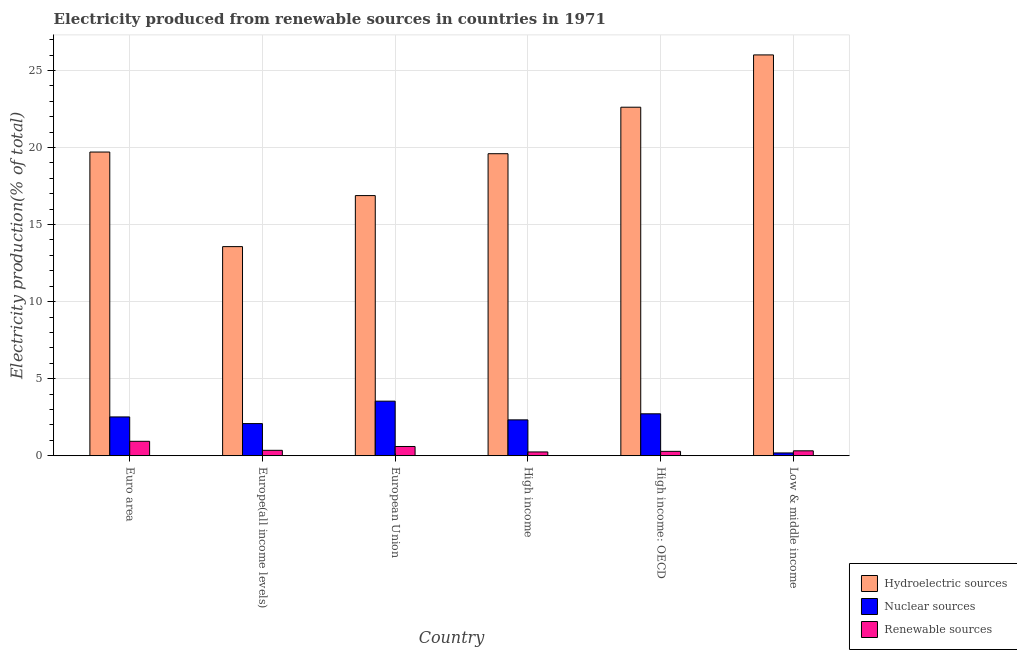How many groups of bars are there?
Your answer should be compact. 6. Are the number of bars on each tick of the X-axis equal?
Your answer should be very brief. Yes. How many bars are there on the 6th tick from the left?
Make the answer very short. 3. How many bars are there on the 4th tick from the right?
Provide a succinct answer. 3. What is the label of the 5th group of bars from the left?
Provide a succinct answer. High income: OECD. In how many cases, is the number of bars for a given country not equal to the number of legend labels?
Your answer should be compact. 0. What is the percentage of electricity produced by hydroelectric sources in High income?
Give a very brief answer. 19.6. Across all countries, what is the maximum percentage of electricity produced by nuclear sources?
Keep it short and to the point. 3.54. Across all countries, what is the minimum percentage of electricity produced by nuclear sources?
Your answer should be compact. 0.18. In which country was the percentage of electricity produced by nuclear sources maximum?
Your answer should be compact. European Union. In which country was the percentage of electricity produced by nuclear sources minimum?
Ensure brevity in your answer.  Low & middle income. What is the total percentage of electricity produced by hydroelectric sources in the graph?
Give a very brief answer. 118.38. What is the difference between the percentage of electricity produced by renewable sources in Europe(all income levels) and that in High income?
Provide a succinct answer. 0.11. What is the difference between the percentage of electricity produced by renewable sources in Euro area and the percentage of electricity produced by hydroelectric sources in Low & middle income?
Provide a short and direct response. -25.07. What is the average percentage of electricity produced by hydroelectric sources per country?
Offer a terse response. 19.73. What is the difference between the percentage of electricity produced by nuclear sources and percentage of electricity produced by renewable sources in Europe(all income levels)?
Offer a terse response. 1.74. What is the ratio of the percentage of electricity produced by nuclear sources in Euro area to that in High income?
Your answer should be very brief. 1.08. Is the difference between the percentage of electricity produced by renewable sources in Europe(all income levels) and Low & middle income greater than the difference between the percentage of electricity produced by hydroelectric sources in Europe(all income levels) and Low & middle income?
Make the answer very short. Yes. What is the difference between the highest and the second highest percentage of electricity produced by hydroelectric sources?
Offer a very short reply. 3.39. What is the difference between the highest and the lowest percentage of electricity produced by hydroelectric sources?
Your answer should be compact. 12.44. In how many countries, is the percentage of electricity produced by hydroelectric sources greater than the average percentage of electricity produced by hydroelectric sources taken over all countries?
Give a very brief answer. 2. Is the sum of the percentage of electricity produced by renewable sources in Europe(all income levels) and High income: OECD greater than the maximum percentage of electricity produced by nuclear sources across all countries?
Offer a very short reply. No. What does the 2nd bar from the left in High income: OECD represents?
Provide a succinct answer. Nuclear sources. What does the 2nd bar from the right in Euro area represents?
Give a very brief answer. Nuclear sources. Is it the case that in every country, the sum of the percentage of electricity produced by hydroelectric sources and percentage of electricity produced by nuclear sources is greater than the percentage of electricity produced by renewable sources?
Provide a succinct answer. Yes. How many bars are there?
Provide a short and direct response. 18. Are all the bars in the graph horizontal?
Make the answer very short. No. How many countries are there in the graph?
Provide a short and direct response. 6. Does the graph contain grids?
Your answer should be compact. Yes. Where does the legend appear in the graph?
Provide a short and direct response. Bottom right. How many legend labels are there?
Offer a very short reply. 3. How are the legend labels stacked?
Ensure brevity in your answer.  Vertical. What is the title of the graph?
Give a very brief answer. Electricity produced from renewable sources in countries in 1971. What is the label or title of the Y-axis?
Ensure brevity in your answer.  Electricity production(% of total). What is the Electricity production(% of total) in Hydroelectric sources in Euro area?
Your response must be concise. 19.71. What is the Electricity production(% of total) in Nuclear sources in Euro area?
Offer a terse response. 2.52. What is the Electricity production(% of total) in Renewable sources in Euro area?
Provide a succinct answer. 0.94. What is the Electricity production(% of total) in Hydroelectric sources in Europe(all income levels)?
Your answer should be very brief. 13.57. What is the Electricity production(% of total) of Nuclear sources in Europe(all income levels)?
Ensure brevity in your answer.  2.09. What is the Electricity production(% of total) of Renewable sources in Europe(all income levels)?
Provide a succinct answer. 0.35. What is the Electricity production(% of total) in Hydroelectric sources in European Union?
Offer a terse response. 16.88. What is the Electricity production(% of total) in Nuclear sources in European Union?
Make the answer very short. 3.54. What is the Electricity production(% of total) in Renewable sources in European Union?
Give a very brief answer. 0.6. What is the Electricity production(% of total) of Hydroelectric sources in High income?
Give a very brief answer. 19.6. What is the Electricity production(% of total) of Nuclear sources in High income?
Provide a short and direct response. 2.33. What is the Electricity production(% of total) in Renewable sources in High income?
Provide a short and direct response. 0.25. What is the Electricity production(% of total) in Hydroelectric sources in High income: OECD?
Give a very brief answer. 22.62. What is the Electricity production(% of total) in Nuclear sources in High income: OECD?
Offer a very short reply. 2.72. What is the Electricity production(% of total) of Renewable sources in High income: OECD?
Make the answer very short. 0.28. What is the Electricity production(% of total) in Hydroelectric sources in Low & middle income?
Ensure brevity in your answer.  26.01. What is the Electricity production(% of total) in Nuclear sources in Low & middle income?
Keep it short and to the point. 0.18. What is the Electricity production(% of total) of Renewable sources in Low & middle income?
Provide a succinct answer. 0.32. Across all countries, what is the maximum Electricity production(% of total) of Hydroelectric sources?
Your response must be concise. 26.01. Across all countries, what is the maximum Electricity production(% of total) in Nuclear sources?
Give a very brief answer. 3.54. Across all countries, what is the maximum Electricity production(% of total) of Renewable sources?
Offer a very short reply. 0.94. Across all countries, what is the minimum Electricity production(% of total) of Hydroelectric sources?
Your response must be concise. 13.57. Across all countries, what is the minimum Electricity production(% of total) in Nuclear sources?
Give a very brief answer. 0.18. Across all countries, what is the minimum Electricity production(% of total) of Renewable sources?
Provide a succinct answer. 0.25. What is the total Electricity production(% of total) in Hydroelectric sources in the graph?
Your response must be concise. 118.38. What is the total Electricity production(% of total) in Nuclear sources in the graph?
Provide a succinct answer. 13.37. What is the total Electricity production(% of total) in Renewable sources in the graph?
Your answer should be compact. 2.73. What is the difference between the Electricity production(% of total) in Hydroelectric sources in Euro area and that in Europe(all income levels)?
Keep it short and to the point. 6.14. What is the difference between the Electricity production(% of total) of Nuclear sources in Euro area and that in Europe(all income levels)?
Ensure brevity in your answer.  0.43. What is the difference between the Electricity production(% of total) in Renewable sources in Euro area and that in Europe(all income levels)?
Your response must be concise. 0.58. What is the difference between the Electricity production(% of total) of Hydroelectric sources in Euro area and that in European Union?
Provide a succinct answer. 2.83. What is the difference between the Electricity production(% of total) in Nuclear sources in Euro area and that in European Union?
Offer a very short reply. -1.02. What is the difference between the Electricity production(% of total) in Renewable sources in Euro area and that in European Union?
Offer a very short reply. 0.34. What is the difference between the Electricity production(% of total) in Hydroelectric sources in Euro area and that in High income?
Make the answer very short. 0.11. What is the difference between the Electricity production(% of total) of Nuclear sources in Euro area and that in High income?
Provide a succinct answer. 0.19. What is the difference between the Electricity production(% of total) of Renewable sources in Euro area and that in High income?
Give a very brief answer. 0.69. What is the difference between the Electricity production(% of total) of Hydroelectric sources in Euro area and that in High income: OECD?
Ensure brevity in your answer.  -2.91. What is the difference between the Electricity production(% of total) of Nuclear sources in Euro area and that in High income: OECD?
Offer a very short reply. -0.2. What is the difference between the Electricity production(% of total) in Renewable sources in Euro area and that in High income: OECD?
Keep it short and to the point. 0.65. What is the difference between the Electricity production(% of total) of Hydroelectric sources in Euro area and that in Low & middle income?
Offer a terse response. -6.3. What is the difference between the Electricity production(% of total) in Nuclear sources in Euro area and that in Low & middle income?
Give a very brief answer. 2.34. What is the difference between the Electricity production(% of total) in Renewable sources in Euro area and that in Low & middle income?
Your answer should be compact. 0.62. What is the difference between the Electricity production(% of total) in Hydroelectric sources in Europe(all income levels) and that in European Union?
Make the answer very short. -3.31. What is the difference between the Electricity production(% of total) of Nuclear sources in Europe(all income levels) and that in European Union?
Make the answer very short. -1.45. What is the difference between the Electricity production(% of total) of Renewable sources in Europe(all income levels) and that in European Union?
Your answer should be compact. -0.25. What is the difference between the Electricity production(% of total) of Hydroelectric sources in Europe(all income levels) and that in High income?
Keep it short and to the point. -6.03. What is the difference between the Electricity production(% of total) of Nuclear sources in Europe(all income levels) and that in High income?
Your answer should be very brief. -0.24. What is the difference between the Electricity production(% of total) in Renewable sources in Europe(all income levels) and that in High income?
Offer a very short reply. 0.11. What is the difference between the Electricity production(% of total) of Hydroelectric sources in Europe(all income levels) and that in High income: OECD?
Your answer should be very brief. -9.05. What is the difference between the Electricity production(% of total) of Nuclear sources in Europe(all income levels) and that in High income: OECD?
Provide a short and direct response. -0.63. What is the difference between the Electricity production(% of total) in Renewable sources in Europe(all income levels) and that in High income: OECD?
Offer a terse response. 0.07. What is the difference between the Electricity production(% of total) of Hydroelectric sources in Europe(all income levels) and that in Low & middle income?
Provide a succinct answer. -12.44. What is the difference between the Electricity production(% of total) in Nuclear sources in Europe(all income levels) and that in Low & middle income?
Provide a short and direct response. 1.9. What is the difference between the Electricity production(% of total) in Renewable sources in Europe(all income levels) and that in Low & middle income?
Offer a very short reply. 0.03. What is the difference between the Electricity production(% of total) in Hydroelectric sources in European Union and that in High income?
Give a very brief answer. -2.72. What is the difference between the Electricity production(% of total) of Nuclear sources in European Union and that in High income?
Make the answer very short. 1.21. What is the difference between the Electricity production(% of total) in Renewable sources in European Union and that in High income?
Offer a terse response. 0.35. What is the difference between the Electricity production(% of total) of Hydroelectric sources in European Union and that in High income: OECD?
Ensure brevity in your answer.  -5.74. What is the difference between the Electricity production(% of total) in Nuclear sources in European Union and that in High income: OECD?
Provide a succinct answer. 0.82. What is the difference between the Electricity production(% of total) in Renewable sources in European Union and that in High income: OECD?
Offer a terse response. 0.32. What is the difference between the Electricity production(% of total) in Hydroelectric sources in European Union and that in Low & middle income?
Make the answer very short. -9.13. What is the difference between the Electricity production(% of total) of Nuclear sources in European Union and that in Low & middle income?
Your response must be concise. 3.36. What is the difference between the Electricity production(% of total) of Renewable sources in European Union and that in Low & middle income?
Your answer should be compact. 0.28. What is the difference between the Electricity production(% of total) in Hydroelectric sources in High income and that in High income: OECD?
Give a very brief answer. -3.02. What is the difference between the Electricity production(% of total) of Nuclear sources in High income and that in High income: OECD?
Make the answer very short. -0.39. What is the difference between the Electricity production(% of total) of Renewable sources in High income and that in High income: OECD?
Make the answer very short. -0.04. What is the difference between the Electricity production(% of total) in Hydroelectric sources in High income and that in Low & middle income?
Offer a very short reply. -6.41. What is the difference between the Electricity production(% of total) in Nuclear sources in High income and that in Low & middle income?
Provide a short and direct response. 2.15. What is the difference between the Electricity production(% of total) of Renewable sources in High income and that in Low & middle income?
Provide a short and direct response. -0.07. What is the difference between the Electricity production(% of total) in Hydroelectric sources in High income: OECD and that in Low & middle income?
Ensure brevity in your answer.  -3.39. What is the difference between the Electricity production(% of total) in Nuclear sources in High income: OECD and that in Low & middle income?
Your answer should be very brief. 2.54. What is the difference between the Electricity production(% of total) of Renewable sources in High income: OECD and that in Low & middle income?
Provide a short and direct response. -0.03. What is the difference between the Electricity production(% of total) of Hydroelectric sources in Euro area and the Electricity production(% of total) of Nuclear sources in Europe(all income levels)?
Your response must be concise. 17.62. What is the difference between the Electricity production(% of total) of Hydroelectric sources in Euro area and the Electricity production(% of total) of Renewable sources in Europe(all income levels)?
Your answer should be compact. 19.36. What is the difference between the Electricity production(% of total) of Nuclear sources in Euro area and the Electricity production(% of total) of Renewable sources in Europe(all income levels)?
Offer a terse response. 2.17. What is the difference between the Electricity production(% of total) of Hydroelectric sources in Euro area and the Electricity production(% of total) of Nuclear sources in European Union?
Your answer should be compact. 16.17. What is the difference between the Electricity production(% of total) of Hydroelectric sources in Euro area and the Electricity production(% of total) of Renewable sources in European Union?
Provide a short and direct response. 19.11. What is the difference between the Electricity production(% of total) in Nuclear sources in Euro area and the Electricity production(% of total) in Renewable sources in European Union?
Ensure brevity in your answer.  1.92. What is the difference between the Electricity production(% of total) in Hydroelectric sources in Euro area and the Electricity production(% of total) in Nuclear sources in High income?
Your answer should be very brief. 17.38. What is the difference between the Electricity production(% of total) in Hydroelectric sources in Euro area and the Electricity production(% of total) in Renewable sources in High income?
Ensure brevity in your answer.  19.46. What is the difference between the Electricity production(% of total) of Nuclear sources in Euro area and the Electricity production(% of total) of Renewable sources in High income?
Your response must be concise. 2.27. What is the difference between the Electricity production(% of total) in Hydroelectric sources in Euro area and the Electricity production(% of total) in Nuclear sources in High income: OECD?
Your answer should be compact. 16.99. What is the difference between the Electricity production(% of total) in Hydroelectric sources in Euro area and the Electricity production(% of total) in Renewable sources in High income: OECD?
Give a very brief answer. 19.42. What is the difference between the Electricity production(% of total) of Nuclear sources in Euro area and the Electricity production(% of total) of Renewable sources in High income: OECD?
Provide a short and direct response. 2.23. What is the difference between the Electricity production(% of total) in Hydroelectric sources in Euro area and the Electricity production(% of total) in Nuclear sources in Low & middle income?
Keep it short and to the point. 19.53. What is the difference between the Electricity production(% of total) of Hydroelectric sources in Euro area and the Electricity production(% of total) of Renewable sources in Low & middle income?
Keep it short and to the point. 19.39. What is the difference between the Electricity production(% of total) of Nuclear sources in Euro area and the Electricity production(% of total) of Renewable sources in Low & middle income?
Ensure brevity in your answer.  2.2. What is the difference between the Electricity production(% of total) of Hydroelectric sources in Europe(all income levels) and the Electricity production(% of total) of Nuclear sources in European Union?
Offer a terse response. 10.03. What is the difference between the Electricity production(% of total) in Hydroelectric sources in Europe(all income levels) and the Electricity production(% of total) in Renewable sources in European Union?
Offer a very short reply. 12.97. What is the difference between the Electricity production(% of total) of Nuclear sources in Europe(all income levels) and the Electricity production(% of total) of Renewable sources in European Union?
Keep it short and to the point. 1.49. What is the difference between the Electricity production(% of total) in Hydroelectric sources in Europe(all income levels) and the Electricity production(% of total) in Nuclear sources in High income?
Your answer should be compact. 11.24. What is the difference between the Electricity production(% of total) of Hydroelectric sources in Europe(all income levels) and the Electricity production(% of total) of Renewable sources in High income?
Keep it short and to the point. 13.32. What is the difference between the Electricity production(% of total) of Nuclear sources in Europe(all income levels) and the Electricity production(% of total) of Renewable sources in High income?
Your answer should be compact. 1.84. What is the difference between the Electricity production(% of total) in Hydroelectric sources in Europe(all income levels) and the Electricity production(% of total) in Nuclear sources in High income: OECD?
Ensure brevity in your answer.  10.85. What is the difference between the Electricity production(% of total) of Hydroelectric sources in Europe(all income levels) and the Electricity production(% of total) of Renewable sources in High income: OECD?
Keep it short and to the point. 13.29. What is the difference between the Electricity production(% of total) in Nuclear sources in Europe(all income levels) and the Electricity production(% of total) in Renewable sources in High income: OECD?
Your answer should be compact. 1.8. What is the difference between the Electricity production(% of total) in Hydroelectric sources in Europe(all income levels) and the Electricity production(% of total) in Nuclear sources in Low & middle income?
Give a very brief answer. 13.39. What is the difference between the Electricity production(% of total) in Hydroelectric sources in Europe(all income levels) and the Electricity production(% of total) in Renewable sources in Low & middle income?
Your response must be concise. 13.25. What is the difference between the Electricity production(% of total) in Nuclear sources in Europe(all income levels) and the Electricity production(% of total) in Renewable sources in Low & middle income?
Keep it short and to the point. 1.77. What is the difference between the Electricity production(% of total) in Hydroelectric sources in European Union and the Electricity production(% of total) in Nuclear sources in High income?
Keep it short and to the point. 14.55. What is the difference between the Electricity production(% of total) of Hydroelectric sources in European Union and the Electricity production(% of total) of Renewable sources in High income?
Your answer should be compact. 16.64. What is the difference between the Electricity production(% of total) of Nuclear sources in European Union and the Electricity production(% of total) of Renewable sources in High income?
Keep it short and to the point. 3.3. What is the difference between the Electricity production(% of total) of Hydroelectric sources in European Union and the Electricity production(% of total) of Nuclear sources in High income: OECD?
Make the answer very short. 14.16. What is the difference between the Electricity production(% of total) in Hydroelectric sources in European Union and the Electricity production(% of total) in Renewable sources in High income: OECD?
Offer a very short reply. 16.6. What is the difference between the Electricity production(% of total) in Nuclear sources in European Union and the Electricity production(% of total) in Renewable sources in High income: OECD?
Provide a succinct answer. 3.26. What is the difference between the Electricity production(% of total) in Hydroelectric sources in European Union and the Electricity production(% of total) in Nuclear sources in Low & middle income?
Your answer should be compact. 16.7. What is the difference between the Electricity production(% of total) in Hydroelectric sources in European Union and the Electricity production(% of total) in Renewable sources in Low & middle income?
Provide a short and direct response. 16.56. What is the difference between the Electricity production(% of total) of Nuclear sources in European Union and the Electricity production(% of total) of Renewable sources in Low & middle income?
Offer a very short reply. 3.22. What is the difference between the Electricity production(% of total) of Hydroelectric sources in High income and the Electricity production(% of total) of Nuclear sources in High income: OECD?
Your answer should be compact. 16.88. What is the difference between the Electricity production(% of total) in Hydroelectric sources in High income and the Electricity production(% of total) in Renewable sources in High income: OECD?
Give a very brief answer. 19.31. What is the difference between the Electricity production(% of total) in Nuclear sources in High income and the Electricity production(% of total) in Renewable sources in High income: OECD?
Provide a short and direct response. 2.04. What is the difference between the Electricity production(% of total) in Hydroelectric sources in High income and the Electricity production(% of total) in Nuclear sources in Low & middle income?
Your answer should be very brief. 19.42. What is the difference between the Electricity production(% of total) in Hydroelectric sources in High income and the Electricity production(% of total) in Renewable sources in Low & middle income?
Provide a succinct answer. 19.28. What is the difference between the Electricity production(% of total) in Nuclear sources in High income and the Electricity production(% of total) in Renewable sources in Low & middle income?
Your answer should be very brief. 2.01. What is the difference between the Electricity production(% of total) of Hydroelectric sources in High income: OECD and the Electricity production(% of total) of Nuclear sources in Low & middle income?
Ensure brevity in your answer.  22.43. What is the difference between the Electricity production(% of total) in Hydroelectric sources in High income: OECD and the Electricity production(% of total) in Renewable sources in Low & middle income?
Offer a terse response. 22.3. What is the difference between the Electricity production(% of total) in Nuclear sources in High income: OECD and the Electricity production(% of total) in Renewable sources in Low & middle income?
Ensure brevity in your answer.  2.4. What is the average Electricity production(% of total) of Hydroelectric sources per country?
Ensure brevity in your answer.  19.73. What is the average Electricity production(% of total) of Nuclear sources per country?
Make the answer very short. 2.23. What is the average Electricity production(% of total) of Renewable sources per country?
Keep it short and to the point. 0.46. What is the difference between the Electricity production(% of total) in Hydroelectric sources and Electricity production(% of total) in Nuclear sources in Euro area?
Your response must be concise. 17.19. What is the difference between the Electricity production(% of total) of Hydroelectric sources and Electricity production(% of total) of Renewable sources in Euro area?
Your response must be concise. 18.77. What is the difference between the Electricity production(% of total) of Nuclear sources and Electricity production(% of total) of Renewable sources in Euro area?
Your response must be concise. 1.58. What is the difference between the Electricity production(% of total) in Hydroelectric sources and Electricity production(% of total) in Nuclear sources in Europe(all income levels)?
Your answer should be compact. 11.48. What is the difference between the Electricity production(% of total) of Hydroelectric sources and Electricity production(% of total) of Renewable sources in Europe(all income levels)?
Offer a terse response. 13.22. What is the difference between the Electricity production(% of total) of Nuclear sources and Electricity production(% of total) of Renewable sources in Europe(all income levels)?
Make the answer very short. 1.74. What is the difference between the Electricity production(% of total) of Hydroelectric sources and Electricity production(% of total) of Nuclear sources in European Union?
Provide a short and direct response. 13.34. What is the difference between the Electricity production(% of total) of Hydroelectric sources and Electricity production(% of total) of Renewable sources in European Union?
Provide a succinct answer. 16.28. What is the difference between the Electricity production(% of total) in Nuclear sources and Electricity production(% of total) in Renewable sources in European Union?
Your answer should be very brief. 2.94. What is the difference between the Electricity production(% of total) of Hydroelectric sources and Electricity production(% of total) of Nuclear sources in High income?
Your answer should be compact. 17.27. What is the difference between the Electricity production(% of total) of Hydroelectric sources and Electricity production(% of total) of Renewable sources in High income?
Keep it short and to the point. 19.35. What is the difference between the Electricity production(% of total) in Nuclear sources and Electricity production(% of total) in Renewable sources in High income?
Keep it short and to the point. 2.08. What is the difference between the Electricity production(% of total) of Hydroelectric sources and Electricity production(% of total) of Nuclear sources in High income: OECD?
Provide a succinct answer. 19.89. What is the difference between the Electricity production(% of total) of Hydroelectric sources and Electricity production(% of total) of Renewable sources in High income: OECD?
Your response must be concise. 22.33. What is the difference between the Electricity production(% of total) of Nuclear sources and Electricity production(% of total) of Renewable sources in High income: OECD?
Your answer should be very brief. 2.44. What is the difference between the Electricity production(% of total) of Hydroelectric sources and Electricity production(% of total) of Nuclear sources in Low & middle income?
Give a very brief answer. 25.83. What is the difference between the Electricity production(% of total) in Hydroelectric sources and Electricity production(% of total) in Renewable sources in Low & middle income?
Offer a very short reply. 25.69. What is the difference between the Electricity production(% of total) in Nuclear sources and Electricity production(% of total) in Renewable sources in Low & middle income?
Your answer should be very brief. -0.14. What is the ratio of the Electricity production(% of total) in Hydroelectric sources in Euro area to that in Europe(all income levels)?
Provide a succinct answer. 1.45. What is the ratio of the Electricity production(% of total) in Nuclear sources in Euro area to that in Europe(all income levels)?
Your response must be concise. 1.21. What is the ratio of the Electricity production(% of total) in Renewable sources in Euro area to that in Europe(all income levels)?
Ensure brevity in your answer.  2.67. What is the ratio of the Electricity production(% of total) in Hydroelectric sources in Euro area to that in European Union?
Ensure brevity in your answer.  1.17. What is the ratio of the Electricity production(% of total) of Nuclear sources in Euro area to that in European Union?
Your answer should be very brief. 0.71. What is the ratio of the Electricity production(% of total) in Renewable sources in Euro area to that in European Union?
Your response must be concise. 1.56. What is the ratio of the Electricity production(% of total) of Hydroelectric sources in Euro area to that in High income?
Provide a short and direct response. 1.01. What is the ratio of the Electricity production(% of total) in Nuclear sources in Euro area to that in High income?
Give a very brief answer. 1.08. What is the ratio of the Electricity production(% of total) in Renewable sources in Euro area to that in High income?
Give a very brief answer. 3.82. What is the ratio of the Electricity production(% of total) of Hydroelectric sources in Euro area to that in High income: OECD?
Make the answer very short. 0.87. What is the ratio of the Electricity production(% of total) of Nuclear sources in Euro area to that in High income: OECD?
Your answer should be compact. 0.93. What is the ratio of the Electricity production(% of total) in Renewable sources in Euro area to that in High income: OECD?
Ensure brevity in your answer.  3.3. What is the ratio of the Electricity production(% of total) in Hydroelectric sources in Euro area to that in Low & middle income?
Provide a short and direct response. 0.76. What is the ratio of the Electricity production(% of total) in Nuclear sources in Euro area to that in Low & middle income?
Your answer should be compact. 13.88. What is the ratio of the Electricity production(% of total) in Renewable sources in Euro area to that in Low & middle income?
Ensure brevity in your answer.  2.94. What is the ratio of the Electricity production(% of total) in Hydroelectric sources in Europe(all income levels) to that in European Union?
Offer a very short reply. 0.8. What is the ratio of the Electricity production(% of total) of Nuclear sources in Europe(all income levels) to that in European Union?
Your answer should be very brief. 0.59. What is the ratio of the Electricity production(% of total) of Renewable sources in Europe(all income levels) to that in European Union?
Offer a terse response. 0.59. What is the ratio of the Electricity production(% of total) of Hydroelectric sources in Europe(all income levels) to that in High income?
Offer a very short reply. 0.69. What is the ratio of the Electricity production(% of total) in Nuclear sources in Europe(all income levels) to that in High income?
Keep it short and to the point. 0.9. What is the ratio of the Electricity production(% of total) in Renewable sources in Europe(all income levels) to that in High income?
Provide a succinct answer. 1.43. What is the ratio of the Electricity production(% of total) of Hydroelectric sources in Europe(all income levels) to that in High income: OECD?
Offer a terse response. 0.6. What is the ratio of the Electricity production(% of total) of Nuclear sources in Europe(all income levels) to that in High income: OECD?
Your answer should be compact. 0.77. What is the ratio of the Electricity production(% of total) of Renewable sources in Europe(all income levels) to that in High income: OECD?
Offer a very short reply. 1.24. What is the ratio of the Electricity production(% of total) of Hydroelectric sources in Europe(all income levels) to that in Low & middle income?
Give a very brief answer. 0.52. What is the ratio of the Electricity production(% of total) in Nuclear sources in Europe(all income levels) to that in Low & middle income?
Offer a terse response. 11.5. What is the ratio of the Electricity production(% of total) of Renewable sources in Europe(all income levels) to that in Low & middle income?
Offer a very short reply. 1.1. What is the ratio of the Electricity production(% of total) in Hydroelectric sources in European Union to that in High income?
Ensure brevity in your answer.  0.86. What is the ratio of the Electricity production(% of total) in Nuclear sources in European Union to that in High income?
Keep it short and to the point. 1.52. What is the ratio of the Electricity production(% of total) of Renewable sources in European Union to that in High income?
Provide a succinct answer. 2.45. What is the ratio of the Electricity production(% of total) in Hydroelectric sources in European Union to that in High income: OECD?
Offer a very short reply. 0.75. What is the ratio of the Electricity production(% of total) in Nuclear sources in European Union to that in High income: OECD?
Provide a succinct answer. 1.3. What is the ratio of the Electricity production(% of total) of Renewable sources in European Union to that in High income: OECD?
Provide a succinct answer. 2.11. What is the ratio of the Electricity production(% of total) in Hydroelectric sources in European Union to that in Low & middle income?
Offer a terse response. 0.65. What is the ratio of the Electricity production(% of total) in Nuclear sources in European Union to that in Low & middle income?
Your answer should be compact. 19.52. What is the ratio of the Electricity production(% of total) of Renewable sources in European Union to that in Low & middle income?
Your answer should be very brief. 1.88. What is the ratio of the Electricity production(% of total) of Hydroelectric sources in High income to that in High income: OECD?
Give a very brief answer. 0.87. What is the ratio of the Electricity production(% of total) in Nuclear sources in High income to that in High income: OECD?
Your answer should be compact. 0.86. What is the ratio of the Electricity production(% of total) in Renewable sources in High income to that in High income: OECD?
Give a very brief answer. 0.86. What is the ratio of the Electricity production(% of total) of Hydroelectric sources in High income to that in Low & middle income?
Offer a terse response. 0.75. What is the ratio of the Electricity production(% of total) in Nuclear sources in High income to that in Low & middle income?
Provide a succinct answer. 12.82. What is the ratio of the Electricity production(% of total) in Renewable sources in High income to that in Low & middle income?
Your answer should be very brief. 0.77. What is the ratio of the Electricity production(% of total) in Hydroelectric sources in High income: OECD to that in Low & middle income?
Your answer should be compact. 0.87. What is the ratio of the Electricity production(% of total) in Nuclear sources in High income: OECD to that in Low & middle income?
Your answer should be compact. 15. What is the ratio of the Electricity production(% of total) in Renewable sources in High income: OECD to that in Low & middle income?
Keep it short and to the point. 0.89. What is the difference between the highest and the second highest Electricity production(% of total) in Hydroelectric sources?
Your answer should be compact. 3.39. What is the difference between the highest and the second highest Electricity production(% of total) in Nuclear sources?
Your answer should be compact. 0.82. What is the difference between the highest and the second highest Electricity production(% of total) in Renewable sources?
Provide a succinct answer. 0.34. What is the difference between the highest and the lowest Electricity production(% of total) of Hydroelectric sources?
Offer a very short reply. 12.44. What is the difference between the highest and the lowest Electricity production(% of total) in Nuclear sources?
Offer a very short reply. 3.36. What is the difference between the highest and the lowest Electricity production(% of total) of Renewable sources?
Offer a terse response. 0.69. 